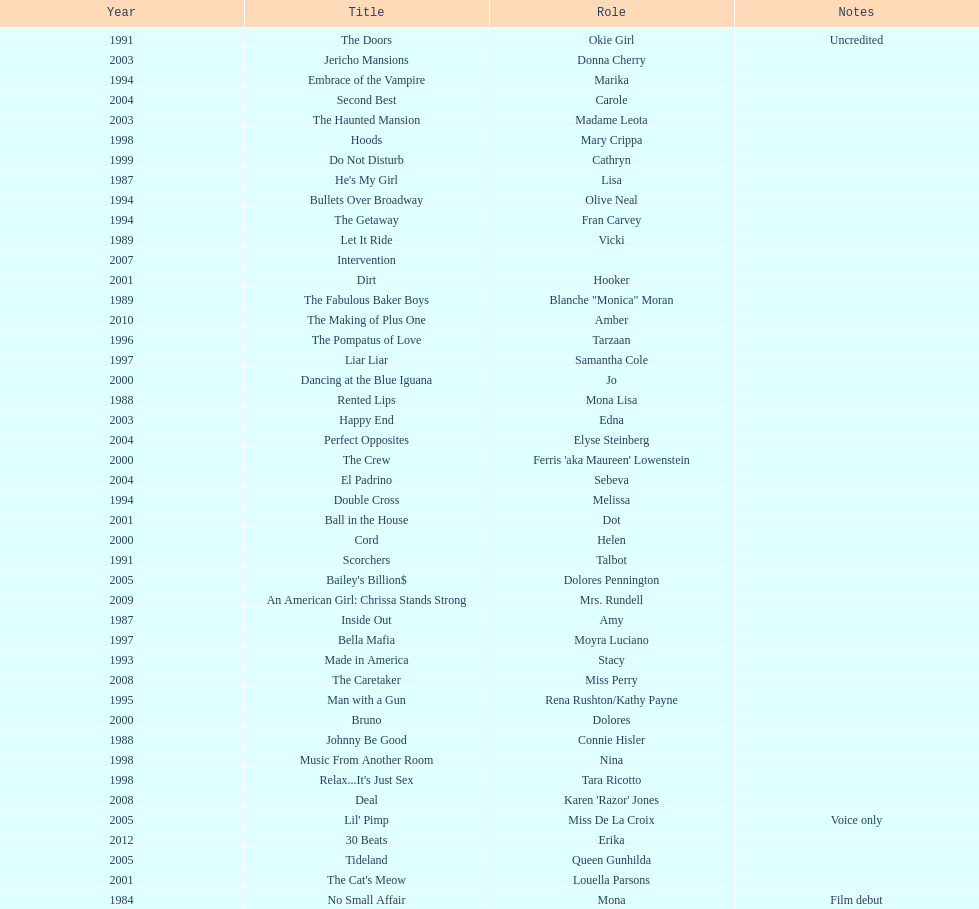Which year had the most credits? 2004. 